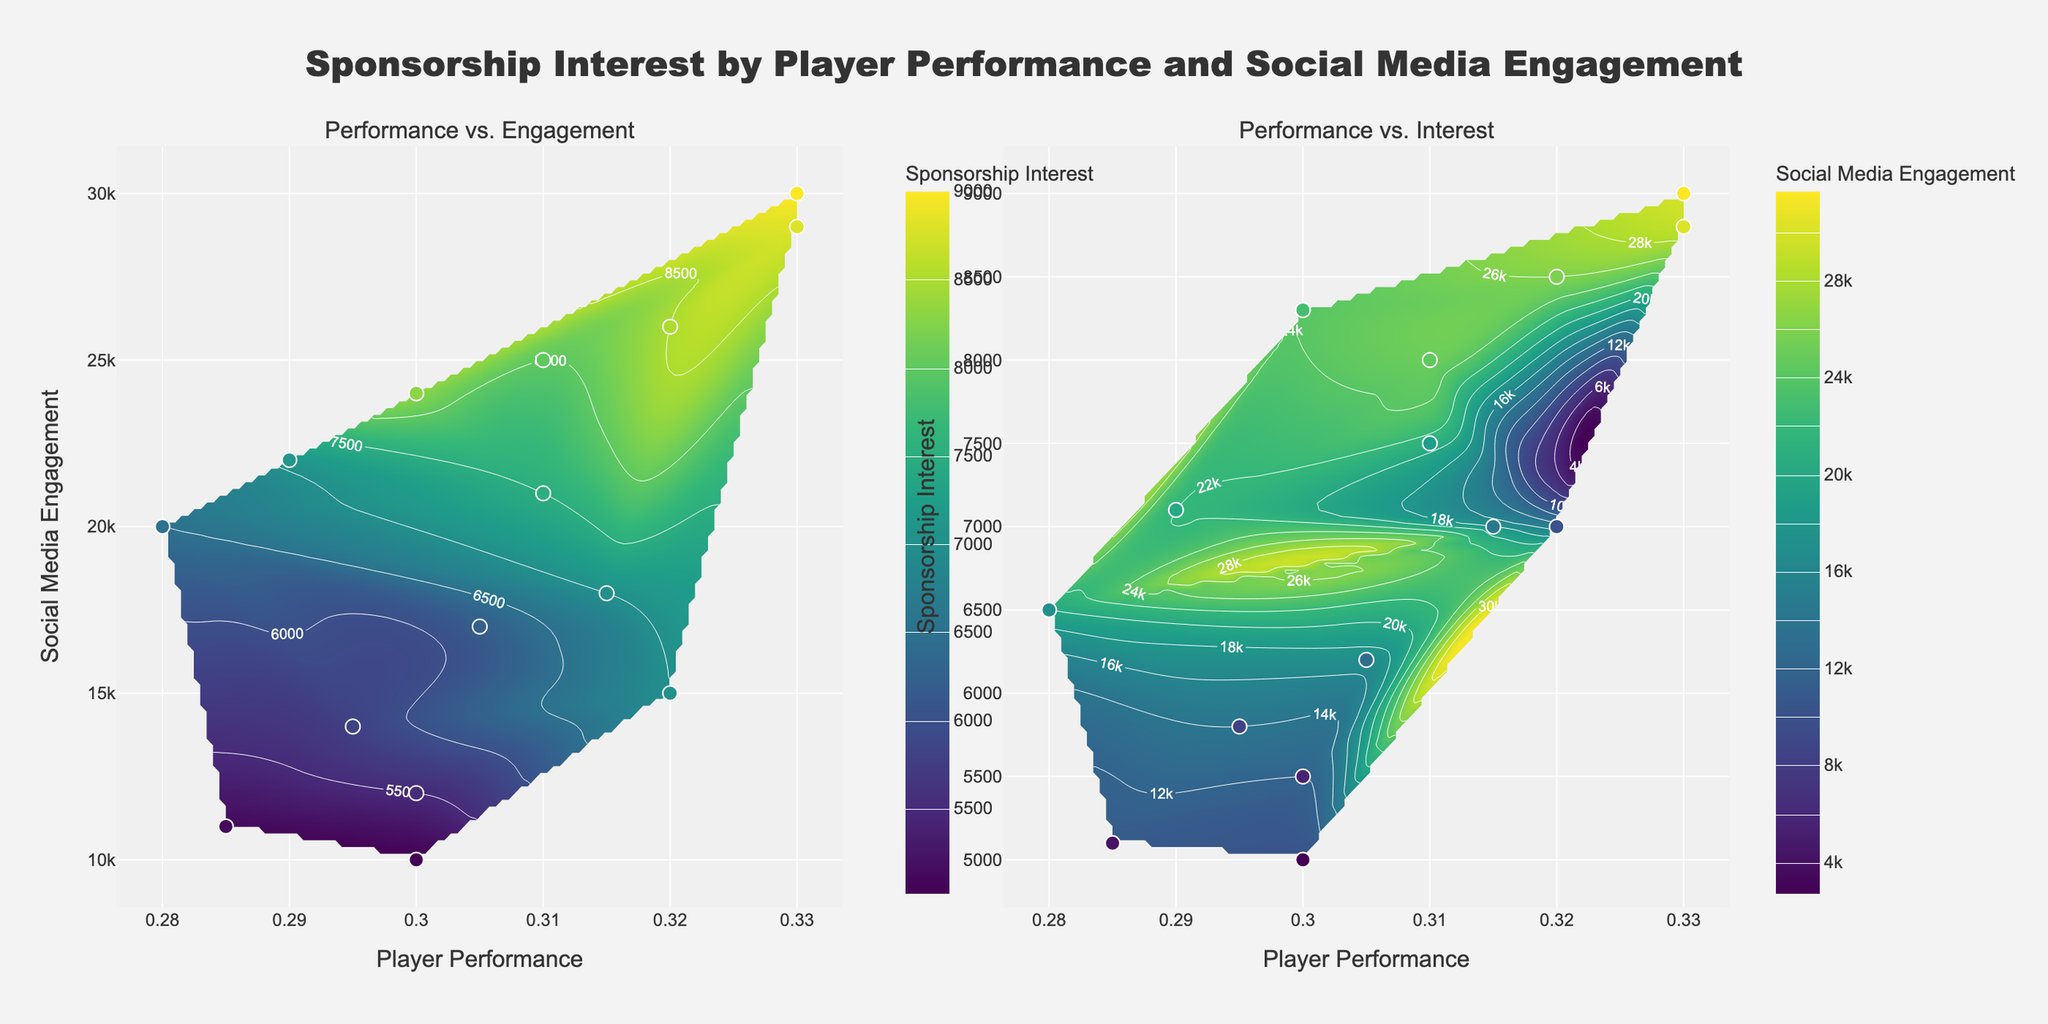What's the title of the figure? The title of the figure is given at the top center and reads "Sponsorship Interest by Player Performance and Social Media Engagement".
Answer: Sponsorship Interest by Player Performance and Social Media Engagement What are the x-axis labels on both subplots? The x-axis on both subplots represents "Player Performance". This is indicated by the label at the bottom of the x-axes.
Answer: Player Performance What data metric is displayed on the color bar in the left subplot? The left subplot's color bar represents "Sponsorship Interest". This is indicated by the color bar's title located beside the color bar itself.
Answer: Sponsorship Interest Which subplot shows the relationship between "Player Performance" and "Sponsorship Interest"? The right subplot shows "Player Performance" on the x-axis and "Sponsorship Interest" on the y-axis.
Answer: Right subplot Which player has the highest "Player Performance" and what is their corresponding "Sponsorship Interest"? Visually inspecting the figure, the player with the highest "Player Performance" is around 0.330, and their corresponding "Sponsorship Interest" is around 9000. This can be inferred from the scatter points and contour gradient.
Answer: 0.330 and 9000 In the right subplot, what is the approximate level of "Social Media Engagement" for a player with a "Player Performance" of 0.300 and a "Sponsorship Interest" of 7200? To find this, locate 0.300 on the x-axis and 7200 on the y-axis of the right subplot. The color gradient and the corresponding color bar suggest "Social Media Engagement" is approximately 24000.
Answer: 24000 How does "Sponsorship Interest" generally relate to "Player Performance" in the left subplot? In the left subplot, higher "Player Performance" values generally correlate with higher "Sponsorship Interest", as indicated by the trend in the contour lines and the location of data points.
Answer: Higher performance relates to higher interest In the left subplot, which player has the lowest "Social Media Engagement" and what is their "Sponsorship Interest"? The lowest "Social Media Engagement" value is 10000, and the corresponding "Sponsorship Interest" for that player is 5000. This can be found by inspecting the lowest y-value and observing the scatter point's color.
Answer: 5000 Which subplot contains more data points with a high correlation between x and y values? The left subplot shows more data points with a clear positive correlation between "Player Performance" and "Social Media Engagement" compared to the right subplot.
Answer: Leftsubplot 